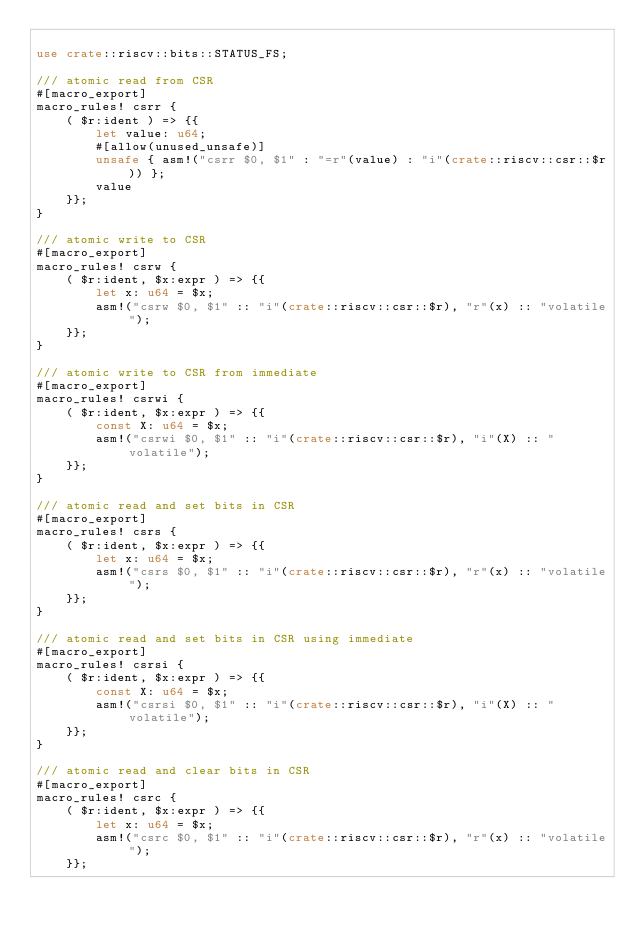<code> <loc_0><loc_0><loc_500><loc_500><_Rust_>
use crate::riscv::bits::STATUS_FS;

/// atomic read from CSR
#[macro_export]
macro_rules! csrr {
    ( $r:ident ) => {{
        let value: u64;
        #[allow(unused_unsafe)]
        unsafe { asm!("csrr $0, $1" : "=r"(value) : "i"(crate::riscv::csr::$r)) };
        value
    }};
}

/// atomic write to CSR
#[macro_export]
macro_rules! csrw {
    ( $r:ident, $x:expr ) => {{
        let x: u64 = $x;
        asm!("csrw $0, $1" :: "i"(crate::riscv::csr::$r), "r"(x) :: "volatile");
    }};
}

/// atomic write to CSR from immediate
#[macro_export]
macro_rules! csrwi {
    ( $r:ident, $x:expr ) => {{
        const X: u64 = $x;
        asm!("csrwi $0, $1" :: "i"(crate::riscv::csr::$r), "i"(X) :: "volatile");
    }};
}

/// atomic read and set bits in CSR
#[macro_export]
macro_rules! csrs {
    ( $r:ident, $x:expr ) => {{
        let x: u64 = $x;
        asm!("csrs $0, $1" :: "i"(crate::riscv::csr::$r), "r"(x) :: "volatile");
    }};
}

/// atomic read and set bits in CSR using immediate
#[macro_export]
macro_rules! csrsi {
    ( $r:ident, $x:expr ) => {{
        const X: u64 = $x;
        asm!("csrsi $0, $1" :: "i"(crate::riscv::csr::$r), "i"(X) :: "volatile");
    }};
}

/// atomic read and clear bits in CSR
#[macro_export]
macro_rules! csrc {
    ( $r:ident, $x:expr ) => {{
        let x: u64 = $x;
        asm!("csrc $0, $1" :: "i"(crate::riscv::csr::$r), "r"(x) :: "volatile");
    }};</code> 